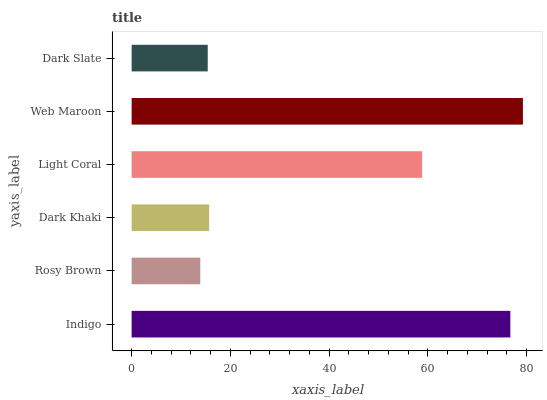Is Rosy Brown the minimum?
Answer yes or no. Yes. Is Web Maroon the maximum?
Answer yes or no. Yes. Is Dark Khaki the minimum?
Answer yes or no. No. Is Dark Khaki the maximum?
Answer yes or no. No. Is Dark Khaki greater than Rosy Brown?
Answer yes or no. Yes. Is Rosy Brown less than Dark Khaki?
Answer yes or no. Yes. Is Rosy Brown greater than Dark Khaki?
Answer yes or no. No. Is Dark Khaki less than Rosy Brown?
Answer yes or no. No. Is Light Coral the high median?
Answer yes or no. Yes. Is Dark Khaki the low median?
Answer yes or no. Yes. Is Dark Slate the high median?
Answer yes or no. No. Is Web Maroon the low median?
Answer yes or no. No. 